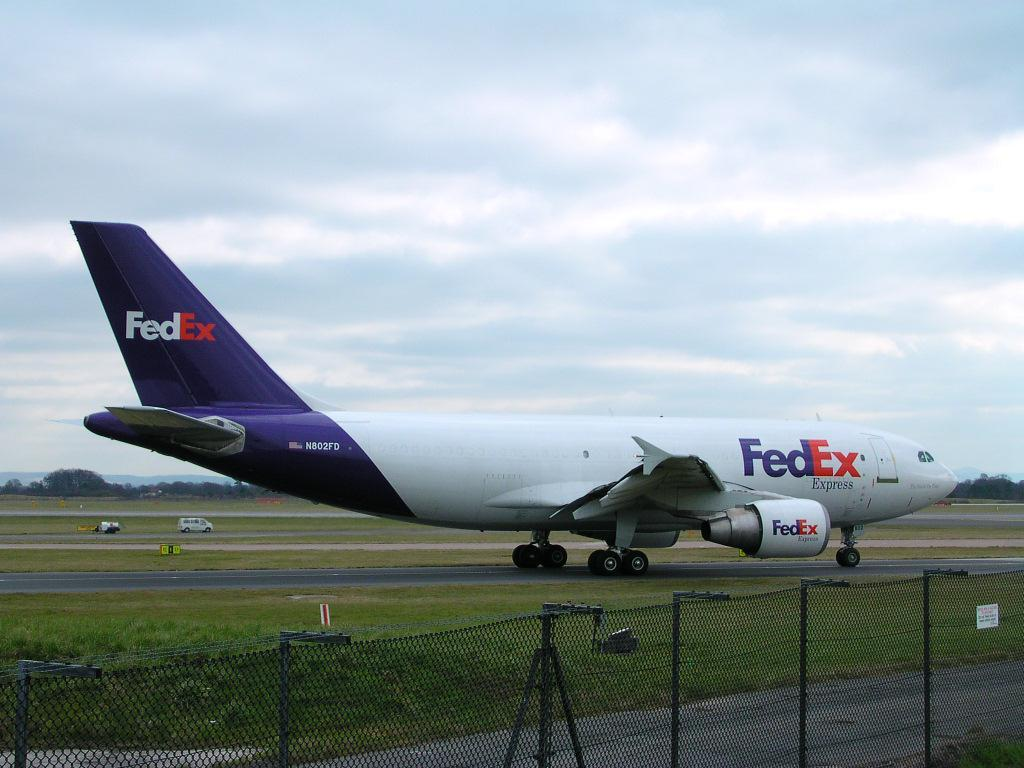Provide a one-sentence caption for the provided image. a large Fedex plane is landed on the tarmack. 